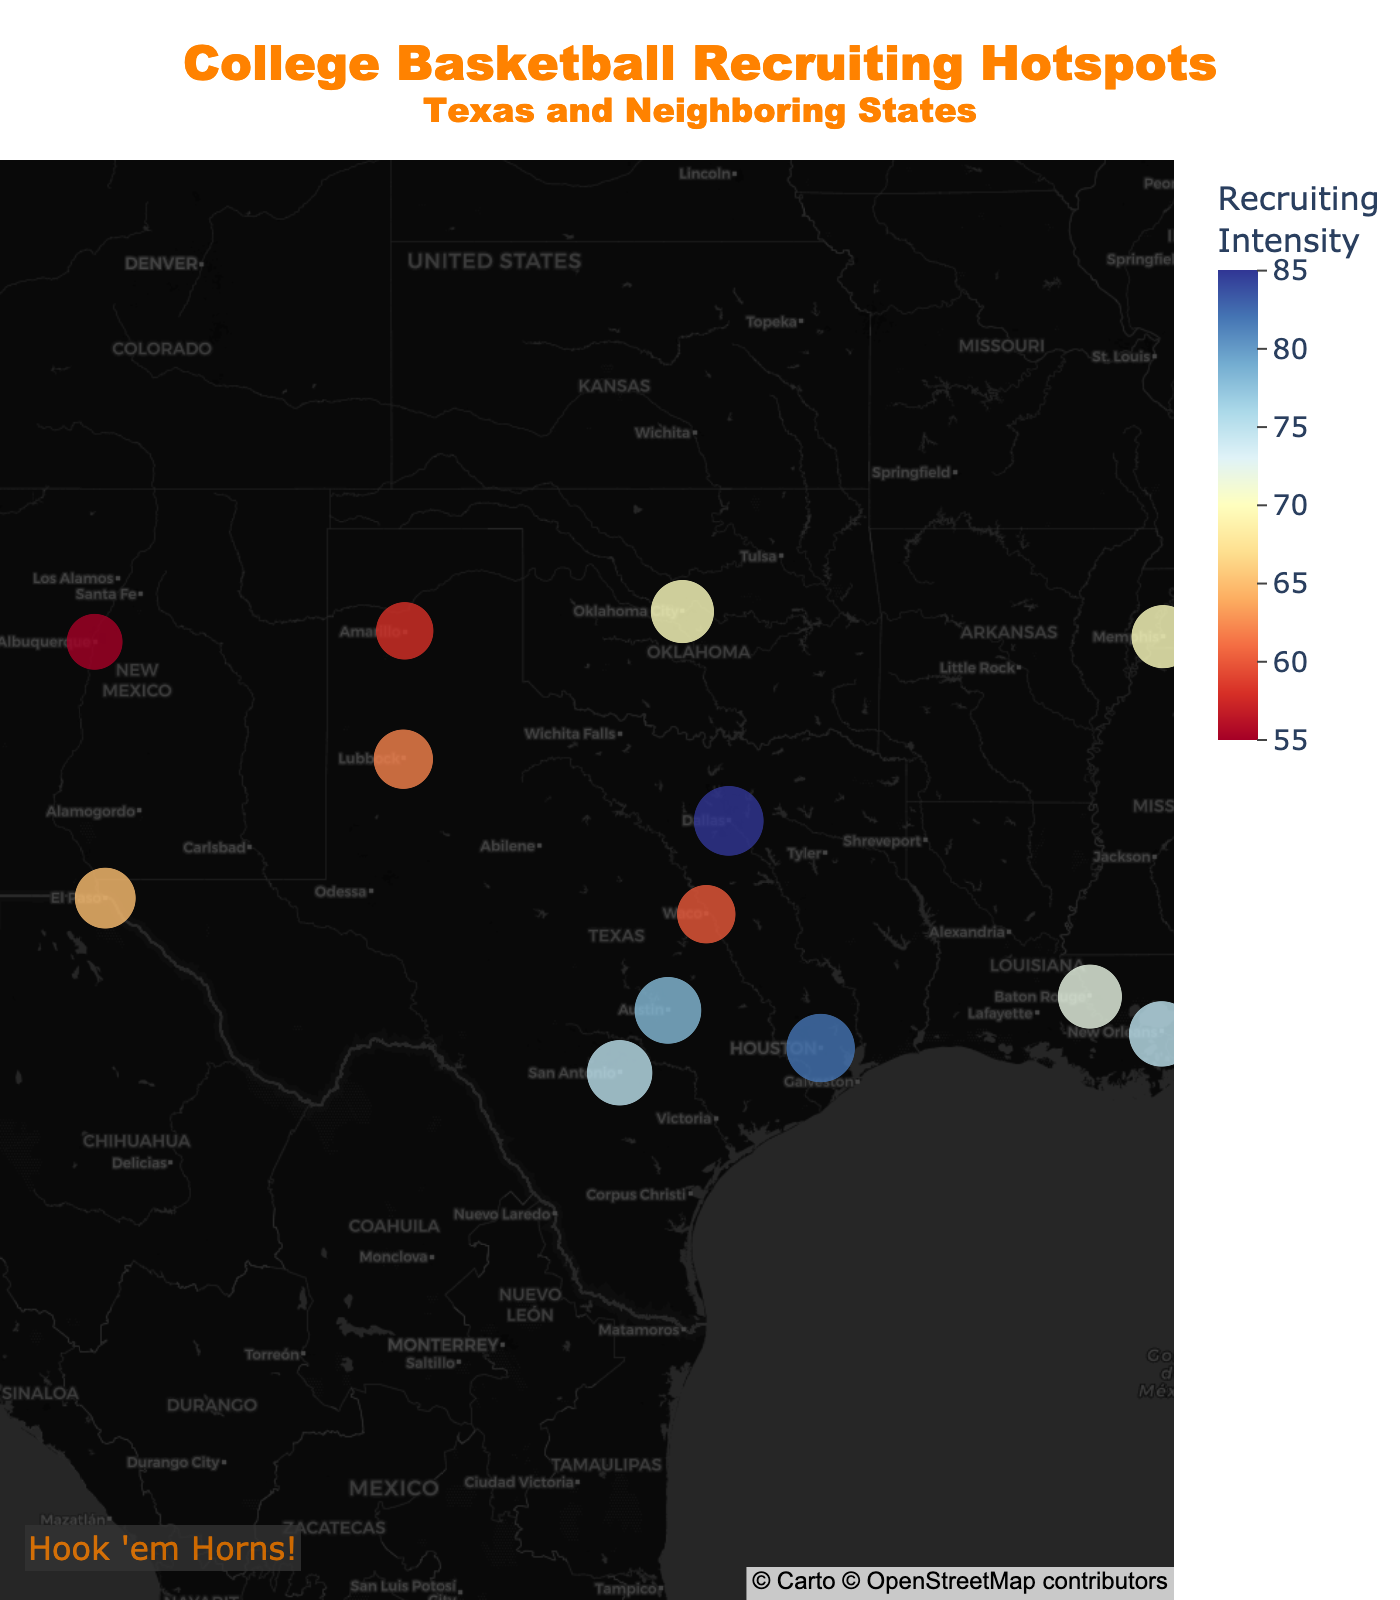What's the title of the figure? The title is prominently displayed at the top of the figure. It reads "College Basketball Recruiting Hotspots" with a subtitle "Texas and Neighboring States".
Answer: College Basketball Recruiting Hotspots What is the recruiting intensity in Dallas? The figure uses size and color to represent recruiting intensity, and hovering over Dallas displays the value directly.
Answer: 85 Which city has the second highest recruiting intensity? By looking at the color and size of the markers, we can identify the top cities. After Dallas with an intensity of 85, Houston comes next with an intensity of 82.
Answer: Houston How many cities in Texas have recruiting intensities higher than 70? From the data points on the map: Dallas (85), Houston (82), Austin (78), San Antonio (75), and El Paso (65). Only Dallas, Houston, Austin, and San Antonio exceed 70.
Answer: 4 What is the total recruiting intensity of all cities in Texas? Sum the recruiting intensities of all Texas cities: Dallas (85), Houston (82), Austin (78), El Paso (65), Amarillo (58), Lubbock (62), Waco (60), San Antonio (75). 85+82+78+65+58+62+60+75 = 565.
Answer: 565 Compare the recruiting intensity between Phoenix, Arizona and Memphis, Tennessee. Which city has a higher intensity? By checking the markers and their respective hover labels, Phoenix has an intensity of 68 while Memphis has 70. Memphis has a slightly higher recruiting intensity.
Answer: Memphis What is the average recruiting intensity of cities in Louisiana? Identify cities in Louisiana: Baton Rouge (72), New Orleans (75). Average = (72 + 75)/2 = 73.5.
Answer: 73.5 Which city is more central on the plot, Austin, Texas or Albuquerque, New Mexico? By observing the geographic center in the plot, Austin appears to be closer to the center than Albuquerque.
Answer: Austin What's the median recruiting intensity of all the cities on the map? List all intensities: 85, 82, 78, 75, 75, 72, 70, 70, 68, 65, 65, 62, 60, 60, 58. Since there are 15 data points, the median is the 8th value in the ordered list: 70.
Answer: 70 Which city in Texas has the lowest recruiting intensity? Observing the markers, Amarillo has the smallest marker and its hover data indicate an intensity of 58.
Answer: Amarillo 